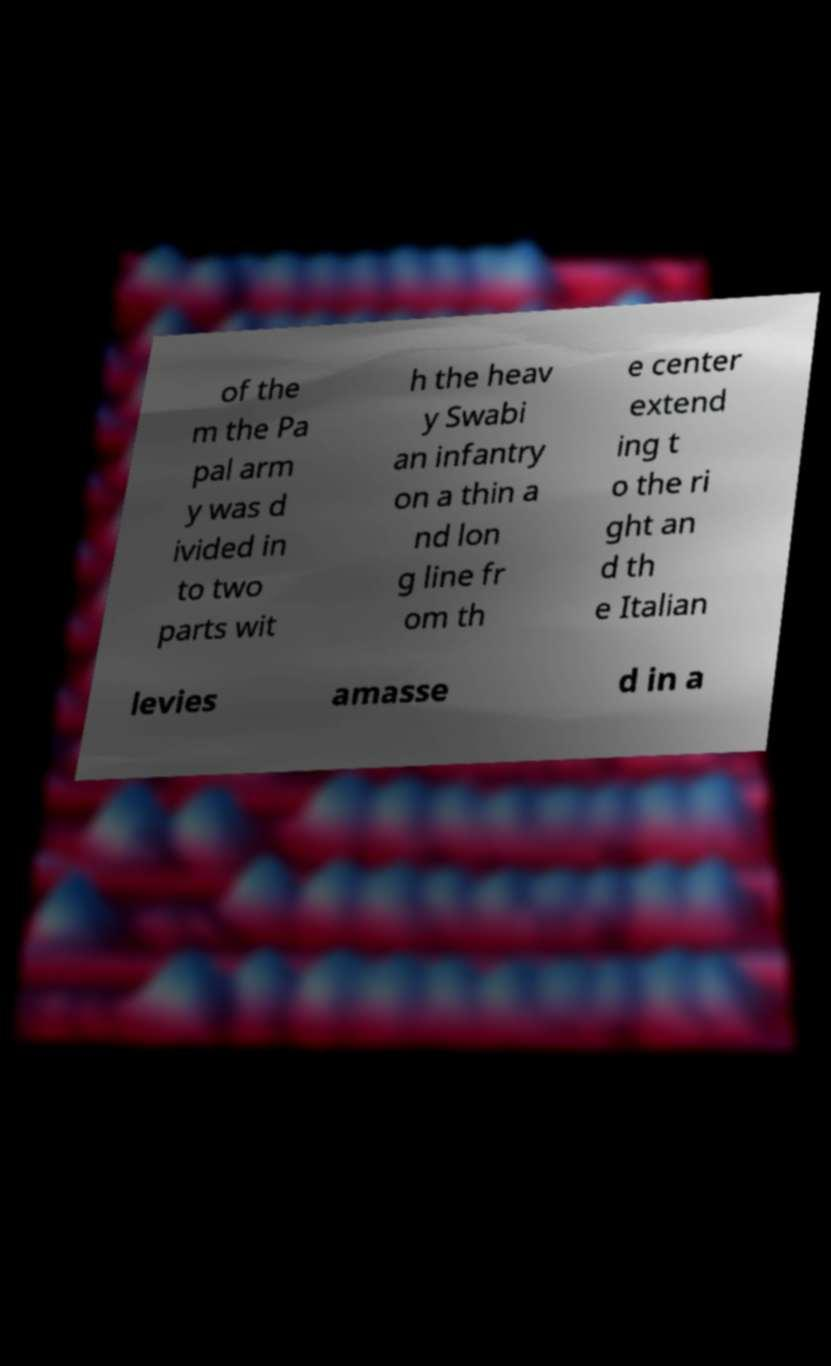For documentation purposes, I need the text within this image transcribed. Could you provide that? of the m the Pa pal arm y was d ivided in to two parts wit h the heav y Swabi an infantry on a thin a nd lon g line fr om th e center extend ing t o the ri ght an d th e Italian levies amasse d in a 